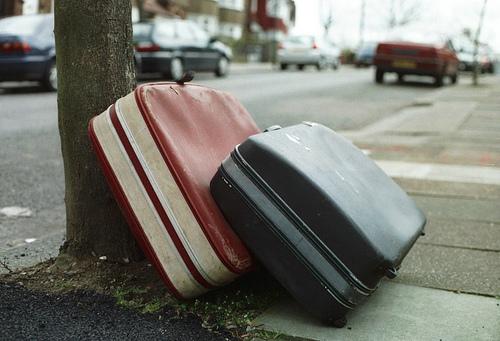Is this an urban or suburban area?
Give a very brief answer. Urban. Is someone waiting for a ride?
Write a very short answer. Yes. How many suitcases are shown?
Keep it brief. 2. 